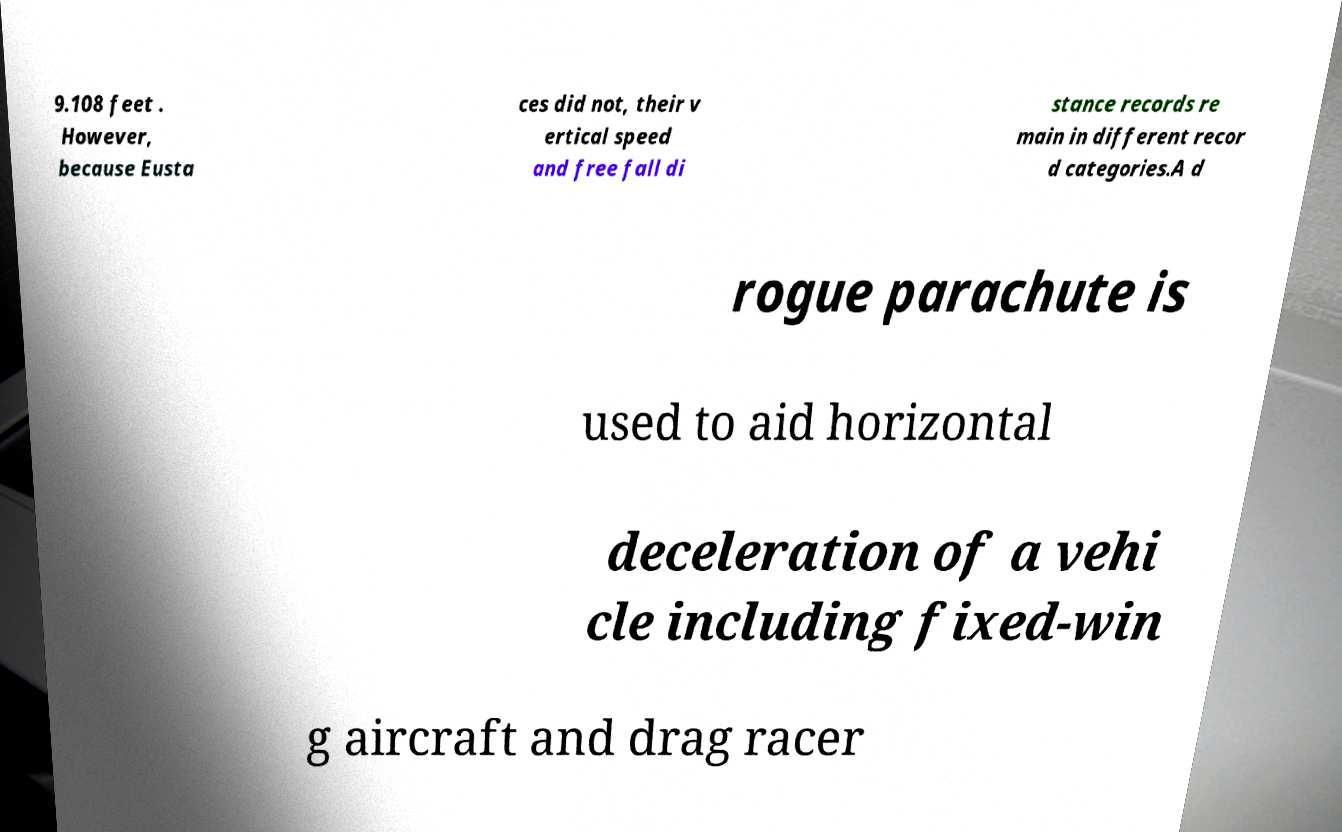Could you assist in decoding the text presented in this image and type it out clearly? 9.108 feet . However, because Eusta ces did not, their v ertical speed and free fall di stance records re main in different recor d categories.A d rogue parachute is used to aid horizontal deceleration of a vehi cle including fixed-win g aircraft and drag racer 